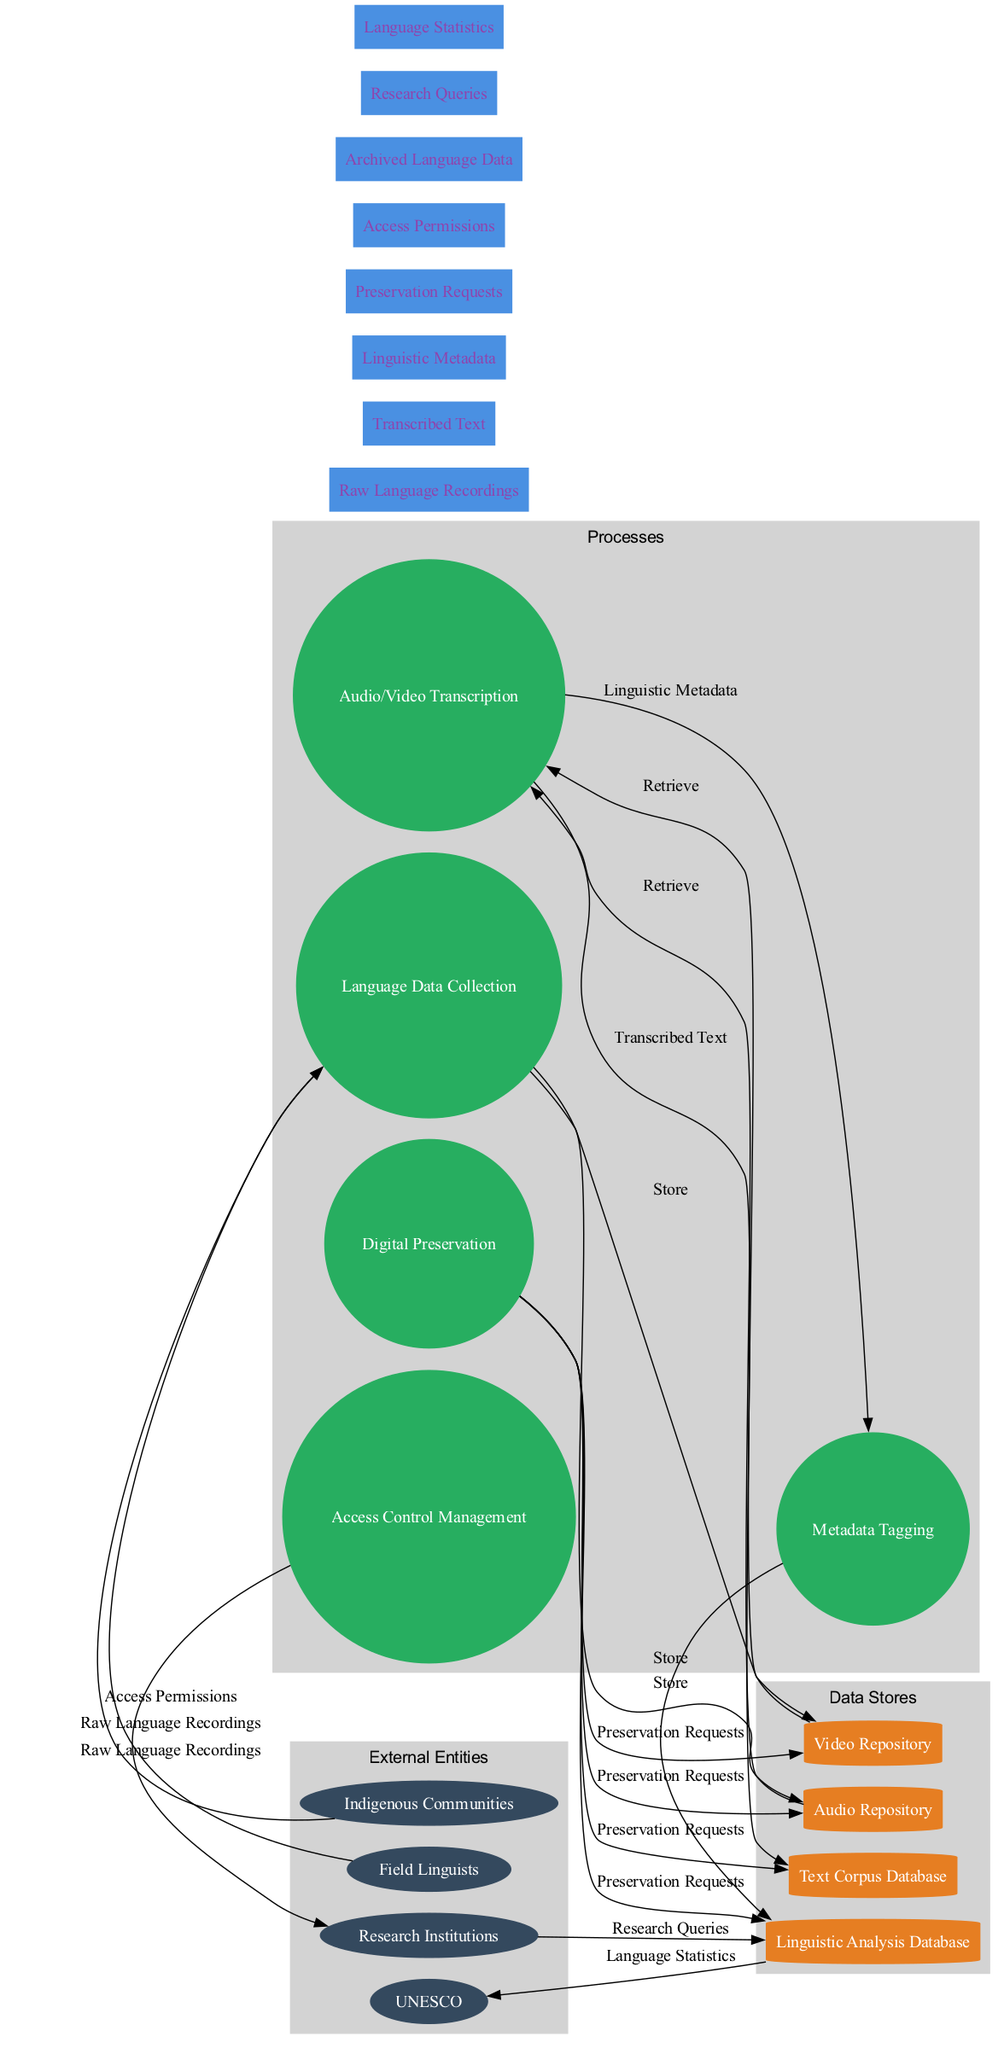What are the external entities in this diagram? The external entities are listed clearly in their respective section of the diagram. They include Field Linguists, Indigenous Communities, Research Institutions, and UNESCO.
Answer: Field Linguists, Indigenous Communities, Research Institutions, UNESCO How many processes are defined in the diagram? To find the number of processes, we can count the unique nodes labeled as processes in the diagram. There are five processes listed: Language Data Collection, Audio/Video Transcription, Metadata Tagging, Digital Preservation, and Access Control Management.
Answer: 5 What type of data flow connects 'Language Data Collection' to the 'Audio Repository'? This data flow is described in the edge connecting these two nodes. The flow is labeled 'Store', indicating that the data collected is stored in the Audio Repository.
Answer: Store Which external entity has a relationship with the process 'Access Control Management'? By tracing the connections, we see that Access Control Management has a direct outgoing flow to Research Institutions, which receives Access Permissions as its output.
Answer: Research Institutions What data flows into the 'Linguistic Analysis Database'? The inputs to the Linguistic Analysis Database can be identified by examining the processes leading into it. The relevant data flows are 'Preservation Requests' and 'Research Queries'.
Answer: Preservation Requests, Research Queries Which data store is associated with 'Audio/Video Transcription'? The data store linked to Audio/Video Transcription can be identified by following the arrow from this process. It clearly shows a connection to both the Text Corpus Database and the Linguistic Analysis Database.
Answer: Text Corpus Database, Linguistic Analysis Database What type of data flow does 'Metadata Tagging' produce? The output from Metadata Tagging can be traced, and it produces 'Linguistic Metadata', which flows into the Linguistic Analysis Database.
Answer: Linguistic Metadata What is the purpose of 'Digital Preservation' in the diagram? Digital Preservation's role involves sending Preservation Requests to various repositories, including Audio Repository, Video Repository, and Text Corpus Database, thus ensuring that these data stores maintain their archived data safely.
Answer: Preservation Requests 